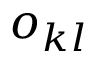Convert formula to latex. <formula><loc_0><loc_0><loc_500><loc_500>o _ { k l }</formula> 